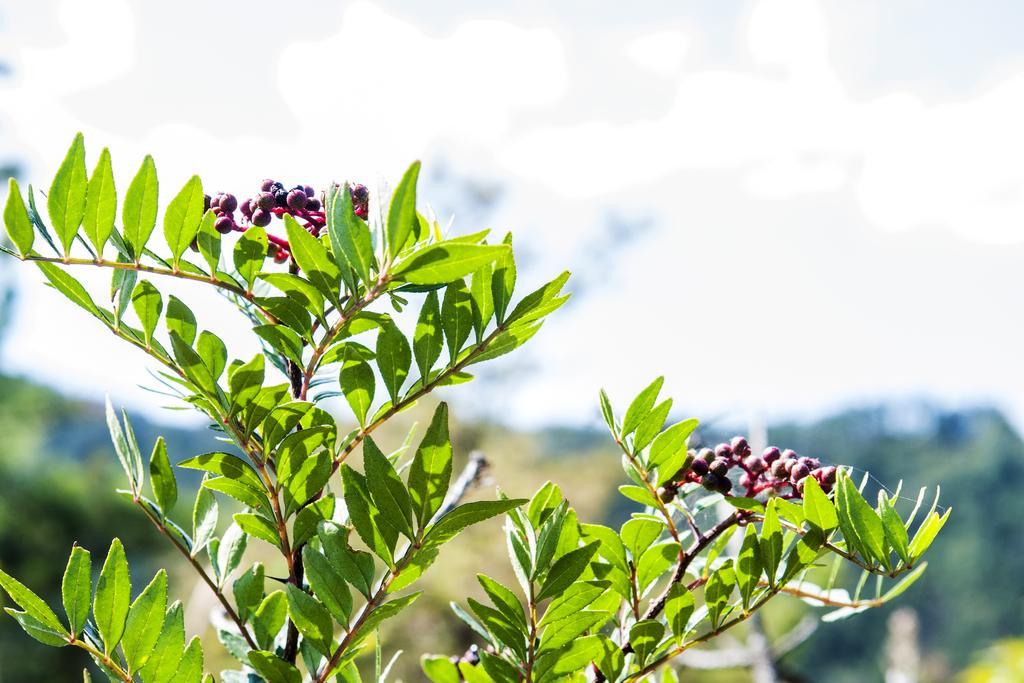In one or two sentences, can you explain what this image depicts? In this picture I can see the leave and berries on the stem and I see that it is totally blurred in the background. 